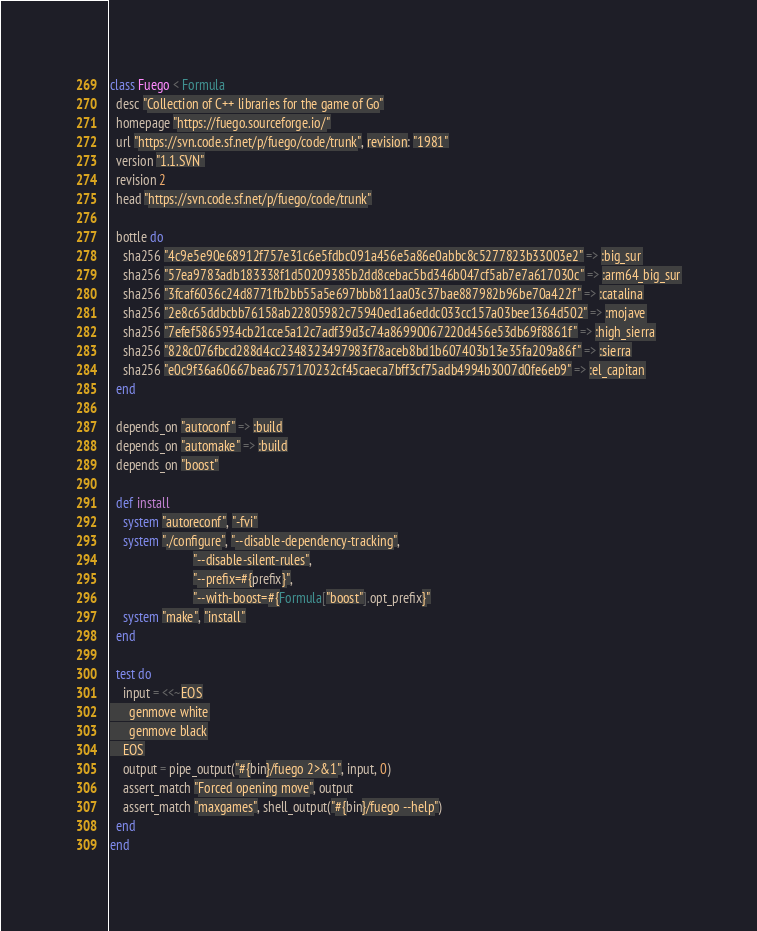Convert code to text. <code><loc_0><loc_0><loc_500><loc_500><_Ruby_>class Fuego < Formula
  desc "Collection of C++ libraries for the game of Go"
  homepage "https://fuego.sourceforge.io/"
  url "https://svn.code.sf.net/p/fuego/code/trunk", revision: "1981"
  version "1.1.SVN"
  revision 2
  head "https://svn.code.sf.net/p/fuego/code/trunk"

  bottle do
    sha256 "4c9e5e90e68912f757e31c6e5fdbc091a456e5a86e0abbc8c5277823b33003e2" => :big_sur
    sha256 "57ea9783adb183338f1d50209385b2dd8cebac5bd346b047cf5ab7e7a617030c" => :arm64_big_sur
    sha256 "3fcaf6036c24d8771fb2bb55a5e697bbb811aa03c37bae887982b96be70a422f" => :catalina
    sha256 "2e8c65ddbcbb76158ab22805982c75940ed1a6eddc033cc157a03bee1364d502" => :mojave
    sha256 "7efef5865934cb21cce5a12c7adf39d3c74a86990067220d456e53db69f8861f" => :high_sierra
    sha256 "828c076fbcd288d4cc2348323497983f78aceb8bd1b607403b13e35fa209a86f" => :sierra
    sha256 "e0c9f36a60667bea6757170232cf45caeca7bff3cf75adb4994b3007d0fe6eb9" => :el_capitan
  end

  depends_on "autoconf" => :build
  depends_on "automake" => :build
  depends_on "boost"

  def install
    system "autoreconf", "-fvi"
    system "./configure", "--disable-dependency-tracking",
                          "--disable-silent-rules",
                          "--prefix=#{prefix}",
                          "--with-boost=#{Formula["boost"].opt_prefix}"
    system "make", "install"
  end

  test do
    input = <<~EOS
      genmove white
      genmove black
    EOS
    output = pipe_output("#{bin}/fuego 2>&1", input, 0)
    assert_match "Forced opening move", output
    assert_match "maxgames", shell_output("#{bin}/fuego --help")
  end
end
</code> 